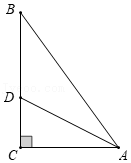First perform reasoning, then finally select the question from the choices in the following format: Answer: xxx.
Question: Suppose we have a diagram representing right triangle ABC, with angle C measuring 90 degrees. The bisector of angle BAC, denoted as AD, intersects side BC at point D. If triangle ACD has an area of 6 square units and the length of side AC is 6 units, what is the length of the segment from point D to AB?
Choices:
A: 1
B: 2
C: 3
D: 4 As shown in the figure, line DE is drawn perpendicular to line AB passing through point D. Since AD bisects angle BAC, DC is perpendicular to AC, and DE is perpendicular to AB, it follows that DC = DE. Given that the area of triangle ACD is 6, we have 0.5 × AC × CD = 6. Solving the equation 0.5 × 6 × CD = 6, we find that CD = 2. Therefore, DE = 2, which means the distance from point D to AB is 2. Thus, the answer is B.
Answer:B 